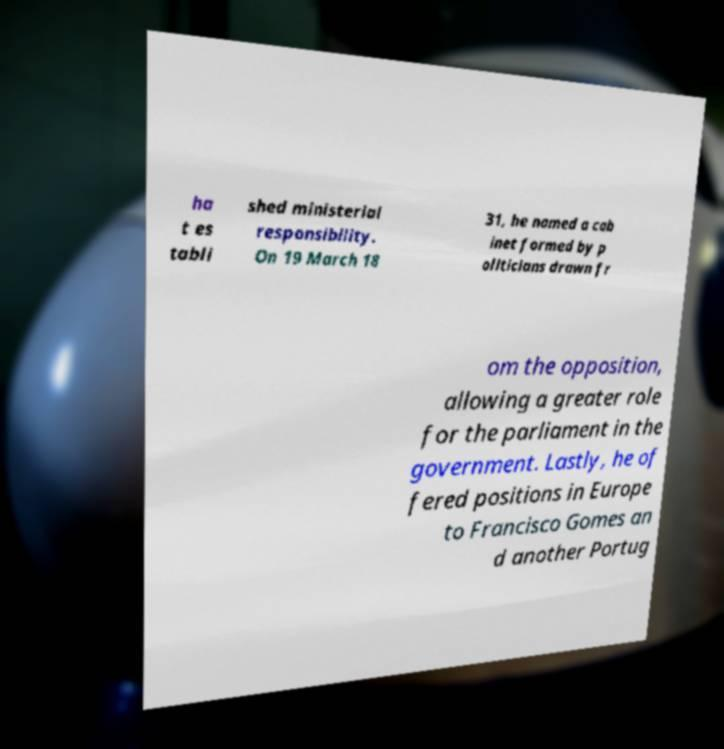What messages or text are displayed in this image? I need them in a readable, typed format. ha t es tabli shed ministerial responsibility. On 19 March 18 31, he named a cab inet formed by p oliticians drawn fr om the opposition, allowing a greater role for the parliament in the government. Lastly, he of fered positions in Europe to Francisco Gomes an d another Portug 